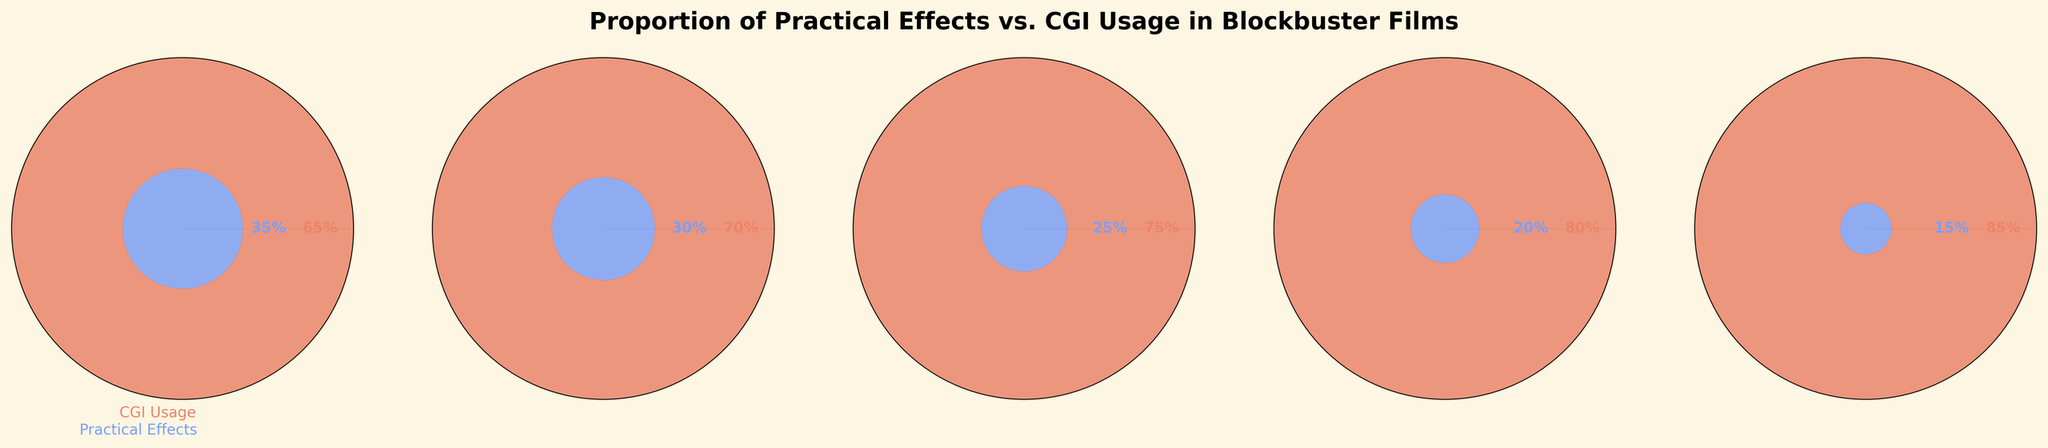Which year had the highest percentage of CGI usage? Looking at each gauge chart, the year 2021 shows the highest CGI usage percentage of 85%.
Answer: 2021 Which year had the highest percentage of practical effects? Reviewing the charts, in 2013, practical effects were at 35%, which is the highest percentage among the displayed years.
Answer: 2013 What is the difference in CGI usage between 2013 and 2021? The chart shows 65% CGI usage in 2013 and 85% in 2021. So, the difference is 85% - 65% = 20%.
Answer: 20% How did the percentage of practical effects change from 2013 to 2021? The figures indicate practical effects decreased from 35% in 2013 to 15% in 2021. The change is 35% - 15% = 20%.
Answer: Decreased by 20% In which years does the percentage of practical effects decrease by exactly 5% compared to the previous data point? Observing the percentages: 35% (2013), 30% (2015), 25% (2017), 20% (2019), 15% (2021). Each year shows a 5% decrease.
Answer: Each year Which year witnessed the smallest drop in practical effects percentage compared to its preceding year? The charts show each year had a consistent decrease of 5%.
Answer: Each year What was the average percentage of CGI usage across all years depicted? Adding up the percentages: 65% (2013) + 70% (2015) + 75% (2017) + 80% (2019) + 85% (2021) = 375%. Dividing by 5 (number of years), the average is 375% / 5 = 75%.
Answer: 75% 